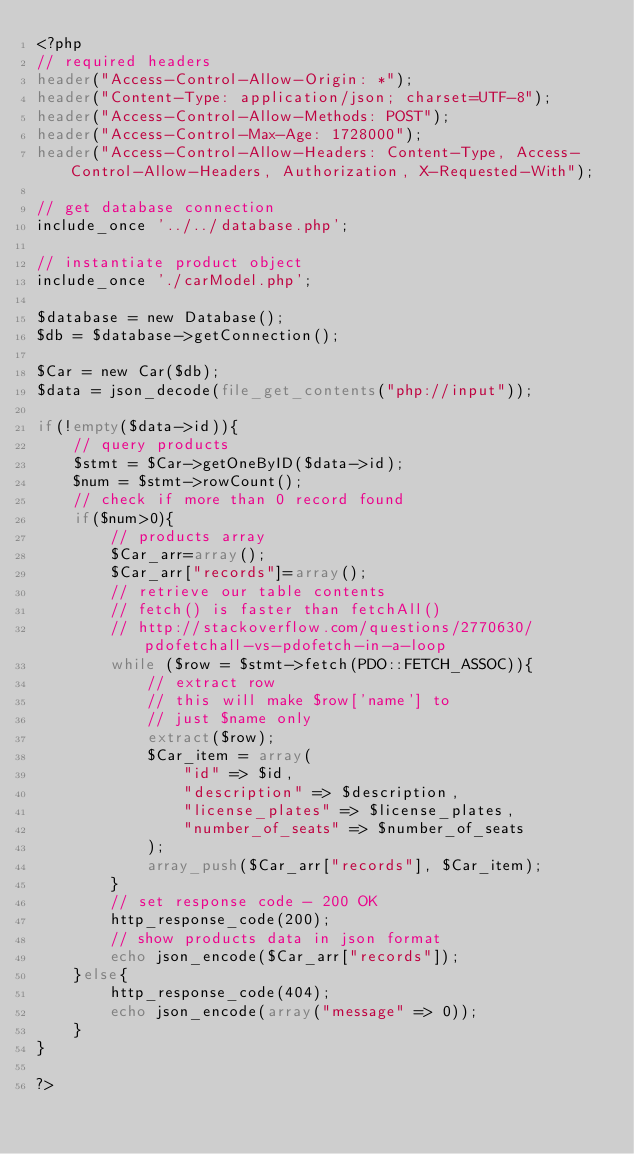Convert code to text. <code><loc_0><loc_0><loc_500><loc_500><_PHP_><?php
// required headers
header("Access-Control-Allow-Origin: *");
header("Content-Type: application/json; charset=UTF-8");
header("Access-Control-Allow-Methods: POST");
header("Access-Control-Max-Age: 1728000");
header("Access-Control-Allow-Headers: Content-Type, Access-Control-Allow-Headers, Authorization, X-Requested-With");
 
// get database connection
include_once '../../database.php';
 
// instantiate product object
include_once './carModel.php';
 
$database = new Database();
$db = $database->getConnection();
 
$Car = new Car($db);
$data = json_decode(file_get_contents("php://input"));

if(!empty($data->id)){
    // query products
    $stmt = $Car->getOneByID($data->id);
    $num = $stmt->rowCount();
    // check if more than 0 record found
    if($num>0){
        // products array
        $Car_arr=array();
        $Car_arr["records"]=array();
        // retrieve our table contents
        // fetch() is faster than fetchAll()
        // http://stackoverflow.com/questions/2770630/pdofetchall-vs-pdofetch-in-a-loop
        while ($row = $stmt->fetch(PDO::FETCH_ASSOC)){ 
            // extract row
            // this will make $row['name'] to
            // just $name only
            extract($row);
            $Car_item = array(
                "id" => $id,
                "description" => $description,
                "license_plates" => $license_plates,
                "number_of_seats" => $number_of_seats
            );
            array_push($Car_arr["records"], $Car_item);
        }
        // set response code - 200 OK
        http_response_code(200);
        // show products data in json format
        echo json_encode($Car_arr["records"]);
    }else{
        http_response_code(404);
        echo json_encode(array("message" => 0));
    }
}

?></code> 